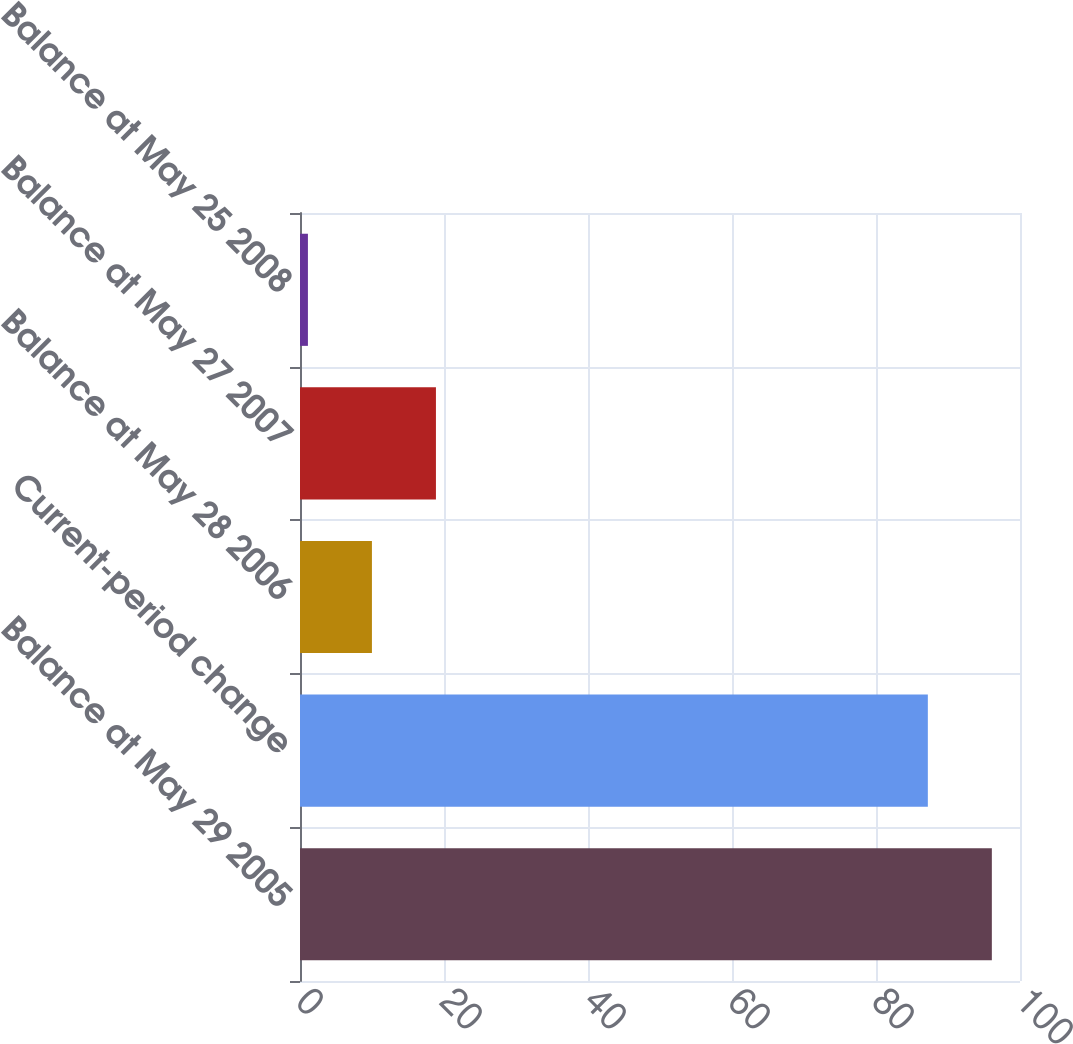Convert chart to OTSL. <chart><loc_0><loc_0><loc_500><loc_500><bar_chart><fcel>Balance at May 29 2005<fcel>Current-period change<fcel>Balance at May 28 2006<fcel>Balance at May 27 2007<fcel>Balance at May 25 2008<nl><fcel>96.09<fcel>87.2<fcel>9.99<fcel>18.88<fcel>1.1<nl></chart> 